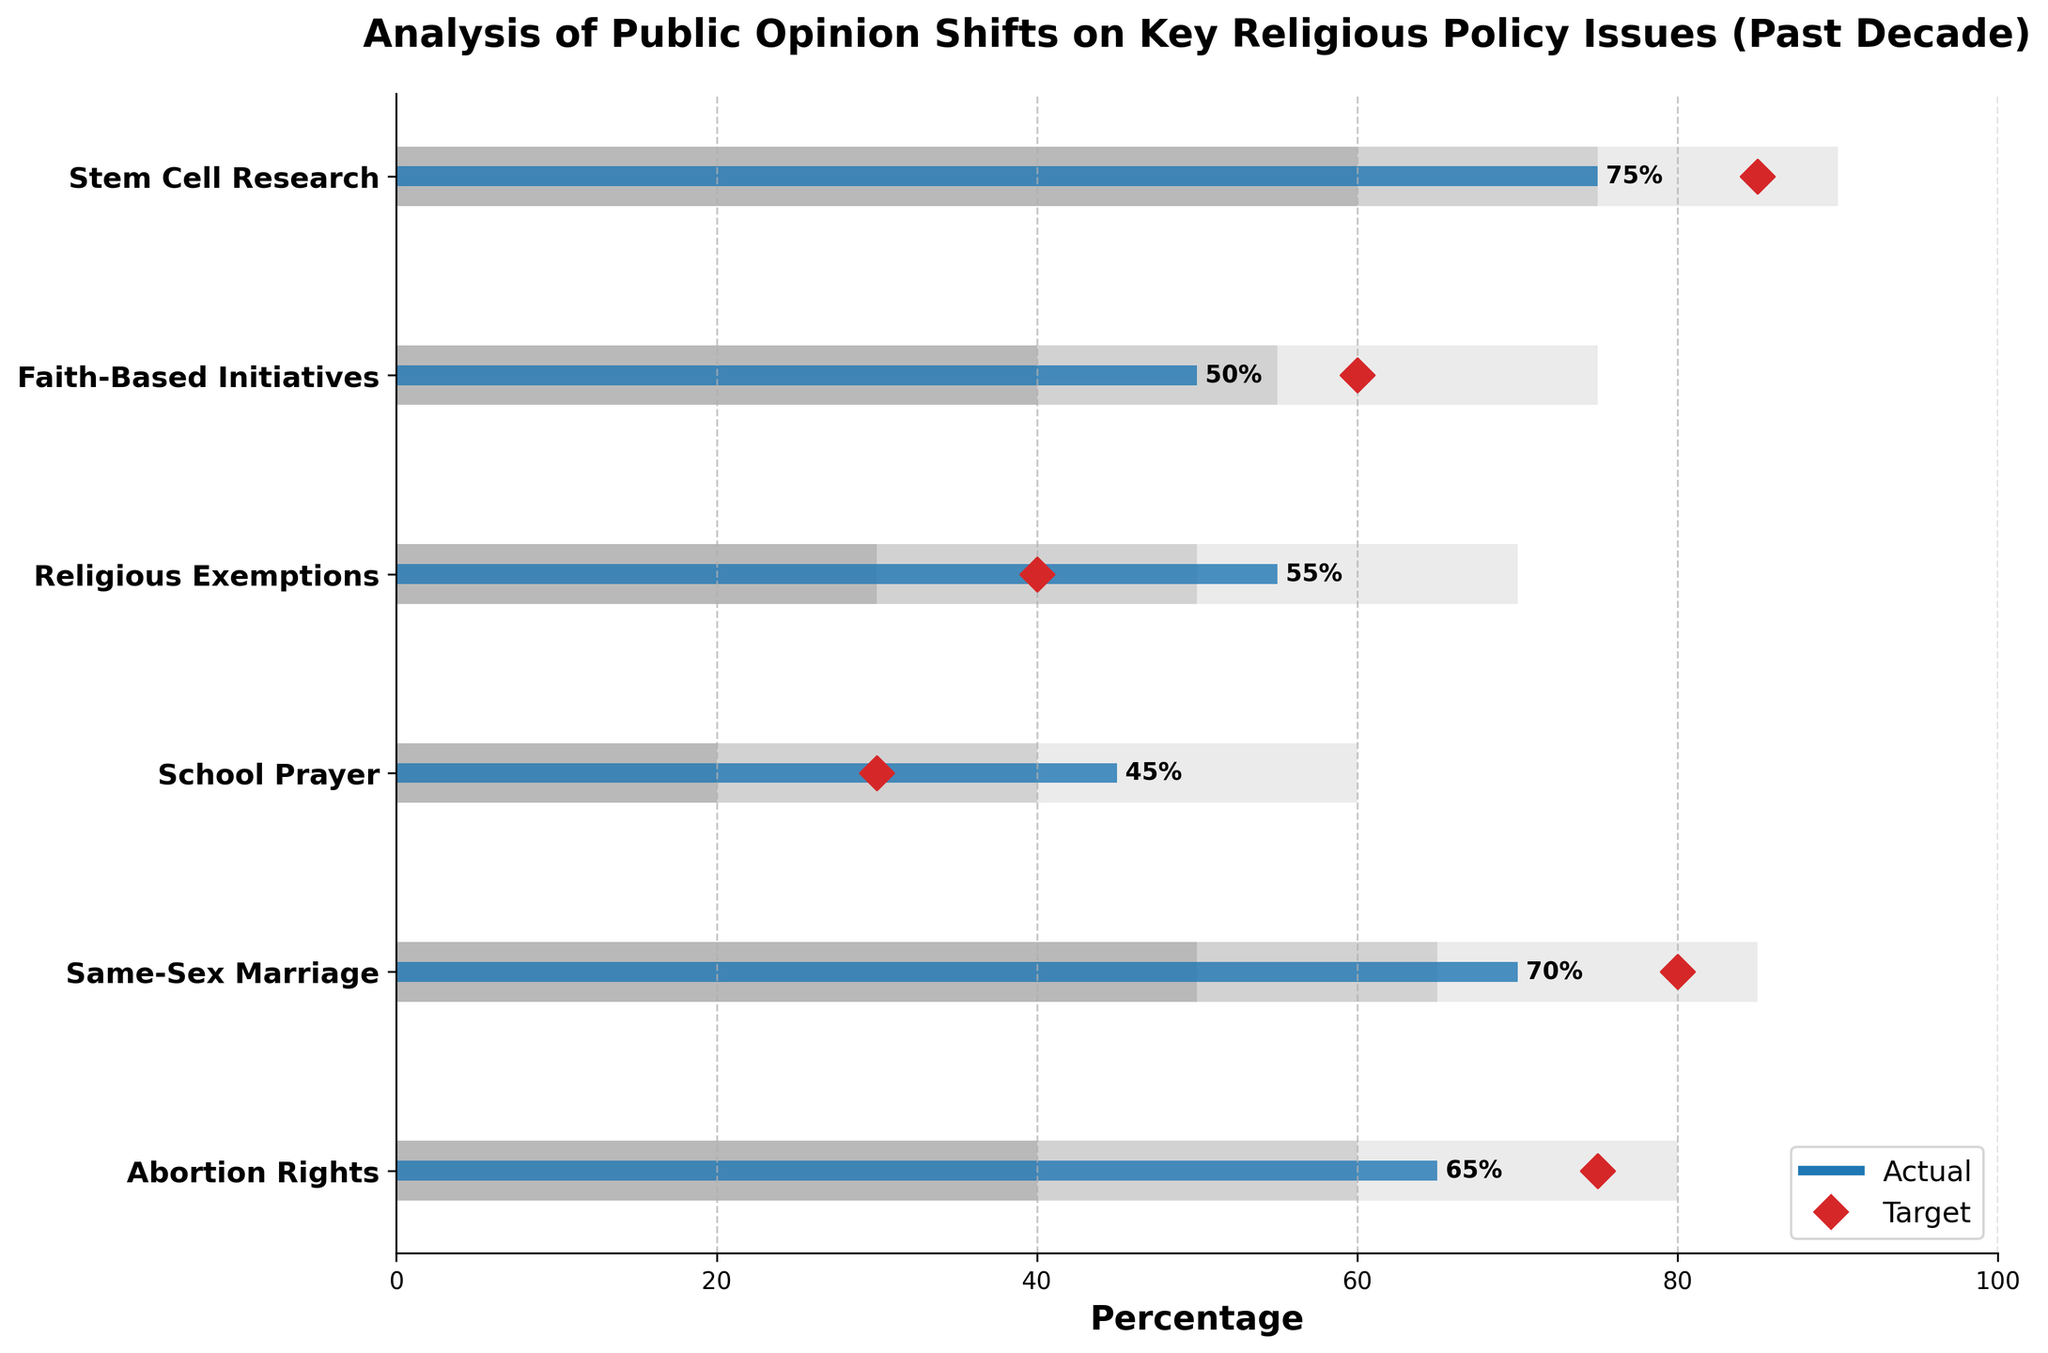what's the title of the figure? The title of the figure is displayed at the top and reads "Analysis of Public Opinion Shifts on Key Religious Policy Issues (Past Decade)."
Answer: Analysis of Public Opinion Shifts on Key Religious Policy Issues (Past Decade) Which policy issue has the highest actual public opinion percentage? By examining the lengths of the blue bars (representing actual values), "Stem Cell Research" has the highest actual public opinion percentage of 75%.
Answer: Stem Cell Research What is the target percentage for public opinion on Same-Sex Marriage, and how does it compare to the actual percentage? The target percentage for Same-Sex Marriage is indicated by the red diamond and is 80%. The actual percentage is 70%, so it is 10% less than the target.
Answer: 80%; 10% less Which policy issue has an actual percentage higher than its target percentage? By comparing the blue bars (actual values) with the red diamonds (target values), "School Prayer" has an actual percentage (45%) higher than its target percentage (30%).
Answer: School Prayer What range does the actual public opinion for Faith-Based Initiatives fall into? The actual percentage for Faith-Based Initiatives is 50%. It falls within the second range, indicated by the light grey bar, which covers the range 40-55%.
Answer: 40-55% Which policy issue shows the smallest gap between actual and target percentages? By observing the distances between blue bars and red diamonds, "Abortion Rights" shows a 10% gap, with an actual percentage of 65% and a target of 75%, which is one of the smallest gaps.
Answer: Abortion Rights What is the range for the highest target percentage value among all the issues? The highest target value is 85% for "Stem Cell Research." This target percentage is within the third range for Stem Cell Research, which covers 75-90%.
Answer: 75-90% For which issues do the actual percentages exceed 50%? By checking the blue bars exceeding the 50% mark, the issues are "Abortion Rights", "Same-Sex Marriage", "Religious Exemptions", and "Stem Cell Research."
Answer: Abortion Rights, Same-Sex Marriage, Religious Exemptions, Stem Cell Research 